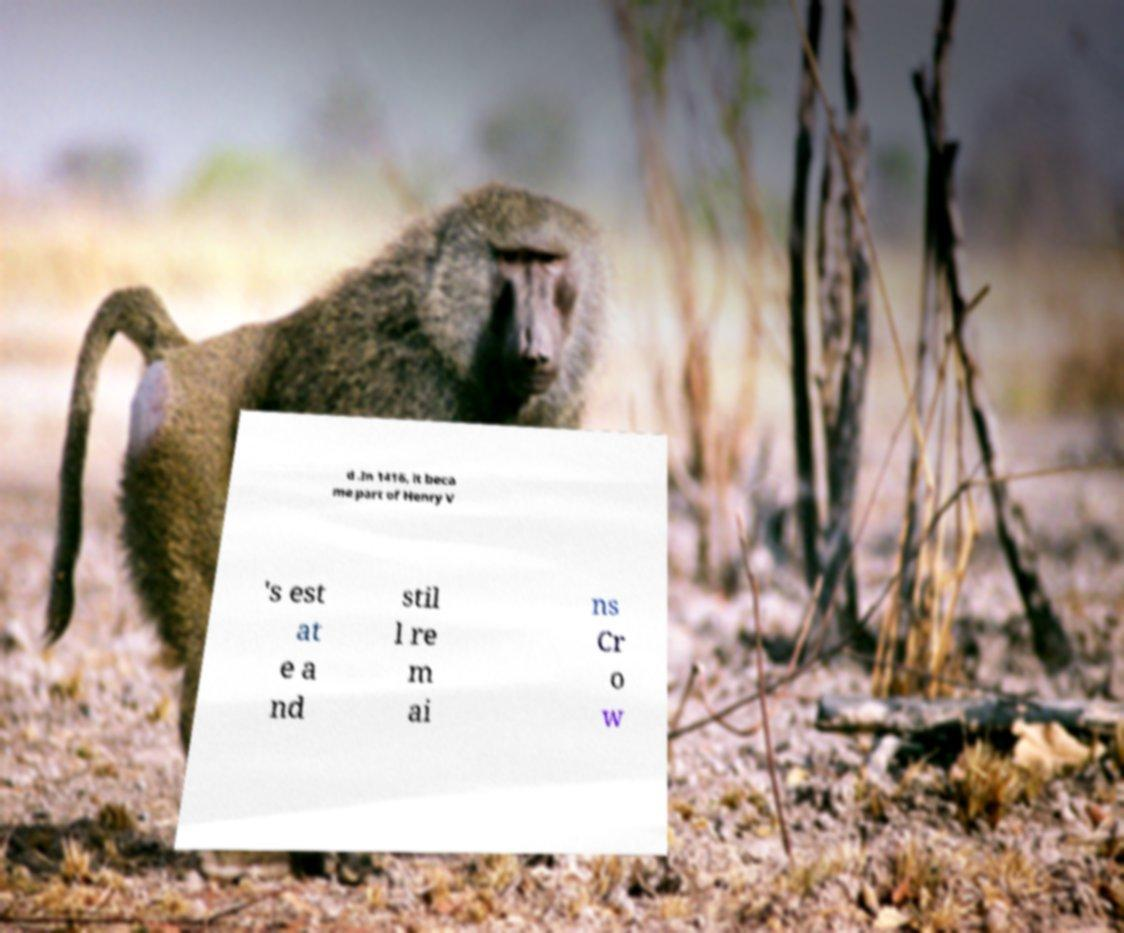Please identify and transcribe the text found in this image. d .In 1416, it beca me part of Henry V 's est at e a nd stil l re m ai ns Cr o w 